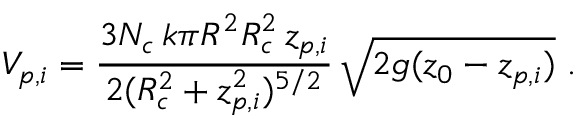<formula> <loc_0><loc_0><loc_500><loc_500>V _ { p , i } = \frac { 3 N _ { c } \, k \pi R ^ { 2 } R _ { c } ^ { 2 } \, z _ { p , i } } { 2 ( R _ { c } ^ { 2 } + z _ { p , i } ^ { 2 } ) ^ { 5 / 2 } } \, \sqrt { 2 g ( z _ { 0 } - z _ { p , i } ) } \, .</formula> 